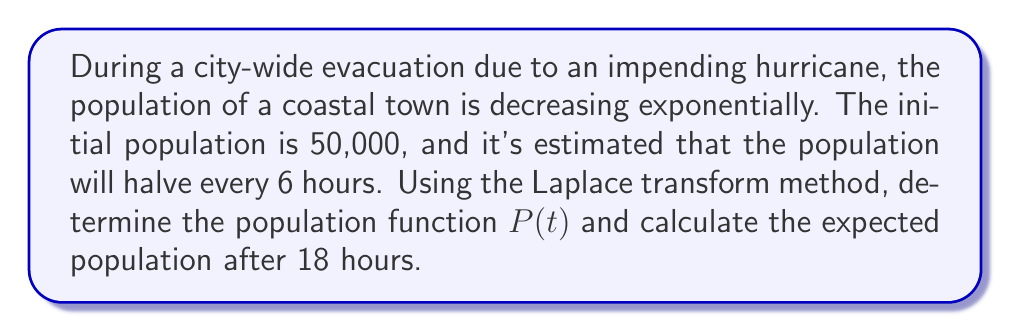Give your solution to this math problem. Let's approach this step-by-step using the Laplace transform method:

1) First, we need to set up our differential equation. The rate of change of population is proportional to the current population:

   $$\frac{dP}{dt} = kP$$

   where $k$ is the decay constant.

2) We're told that the population halves every 6 hours. We can use this to find $k$:

   $$\frac{1}{2} = e^{6k}$$
   $$\ln(\frac{1}{2}) = 6k$$
   $$k = \frac{\ln(1/2)}{6} = -0.1155$$

3) Now our differential equation is:

   $$\frac{dP}{dt} = -0.1155P$$

4) Taking the Laplace transform of both sides:

   $$\mathcal{L}\{\frac{dP}{dt}\} = \mathcal{L}\{-0.1155P\}$$
   $$s\mathcal{L}\{P\} - P(0) = -0.1155\mathcal{L}\{P\}$$

5) Let $\mathcal{L}\{P\} = F(s)$. Then:

   $$sF(s) - 50000 = -0.1155F(s)$$

6) Solving for $F(s)$:

   $$F(s) = \frac{50000}{s + 0.1155}$$

7) The inverse Laplace transform of this is:

   $$P(t) = 50000e^{-0.1155t}$$

8) To find the population after 18 hours, we substitute $t = 18$:

   $$P(18) = 50000e^{-0.1155 * 18} = 50000e^{-2.079} = 6250$$

Therefore, the population function is $P(t) = 50000e^{-0.1155t}$, and the expected population after 18 hours is approximately 6,250 people.
Answer: Population function: $P(t) = 50000e^{-0.1155t}$
Population after 18 hours: 6,250 people (rounded to nearest whole number) 